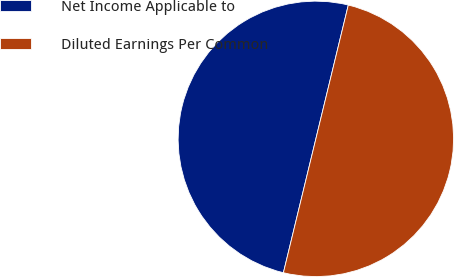Convert chart to OTSL. <chart><loc_0><loc_0><loc_500><loc_500><pie_chart><fcel>Net Income Applicable to<fcel>Diluted Earnings Per Common<nl><fcel>50.0%<fcel>50.0%<nl></chart> 